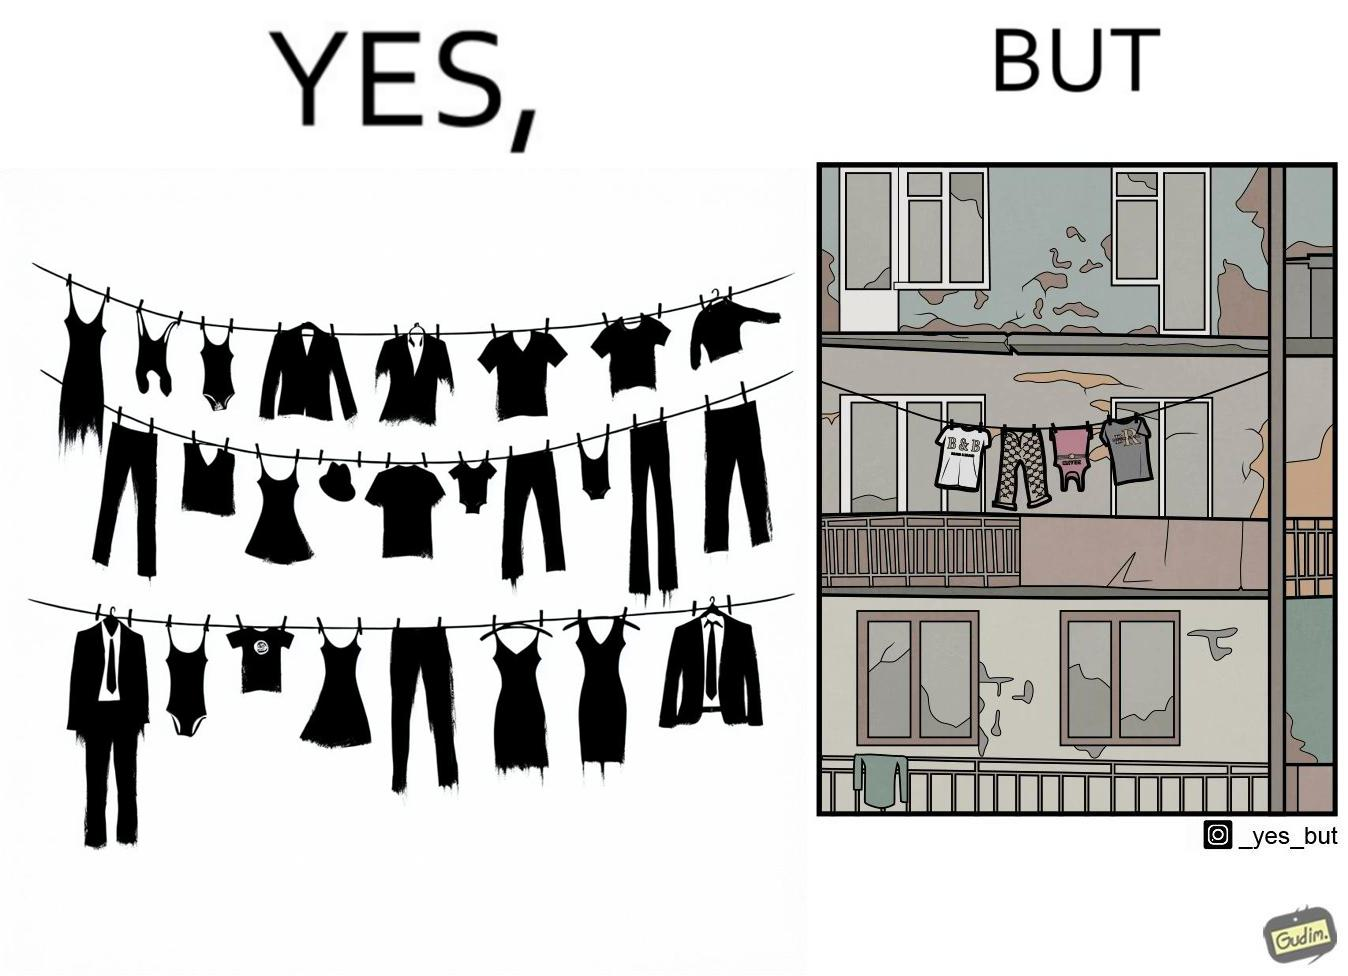Describe what you see in the left and right parts of this image. In the left part of the image: The image is showing branded clothes hanging on a wire. In the right part of the image: The image is showing a very old, dirty and broken house. 